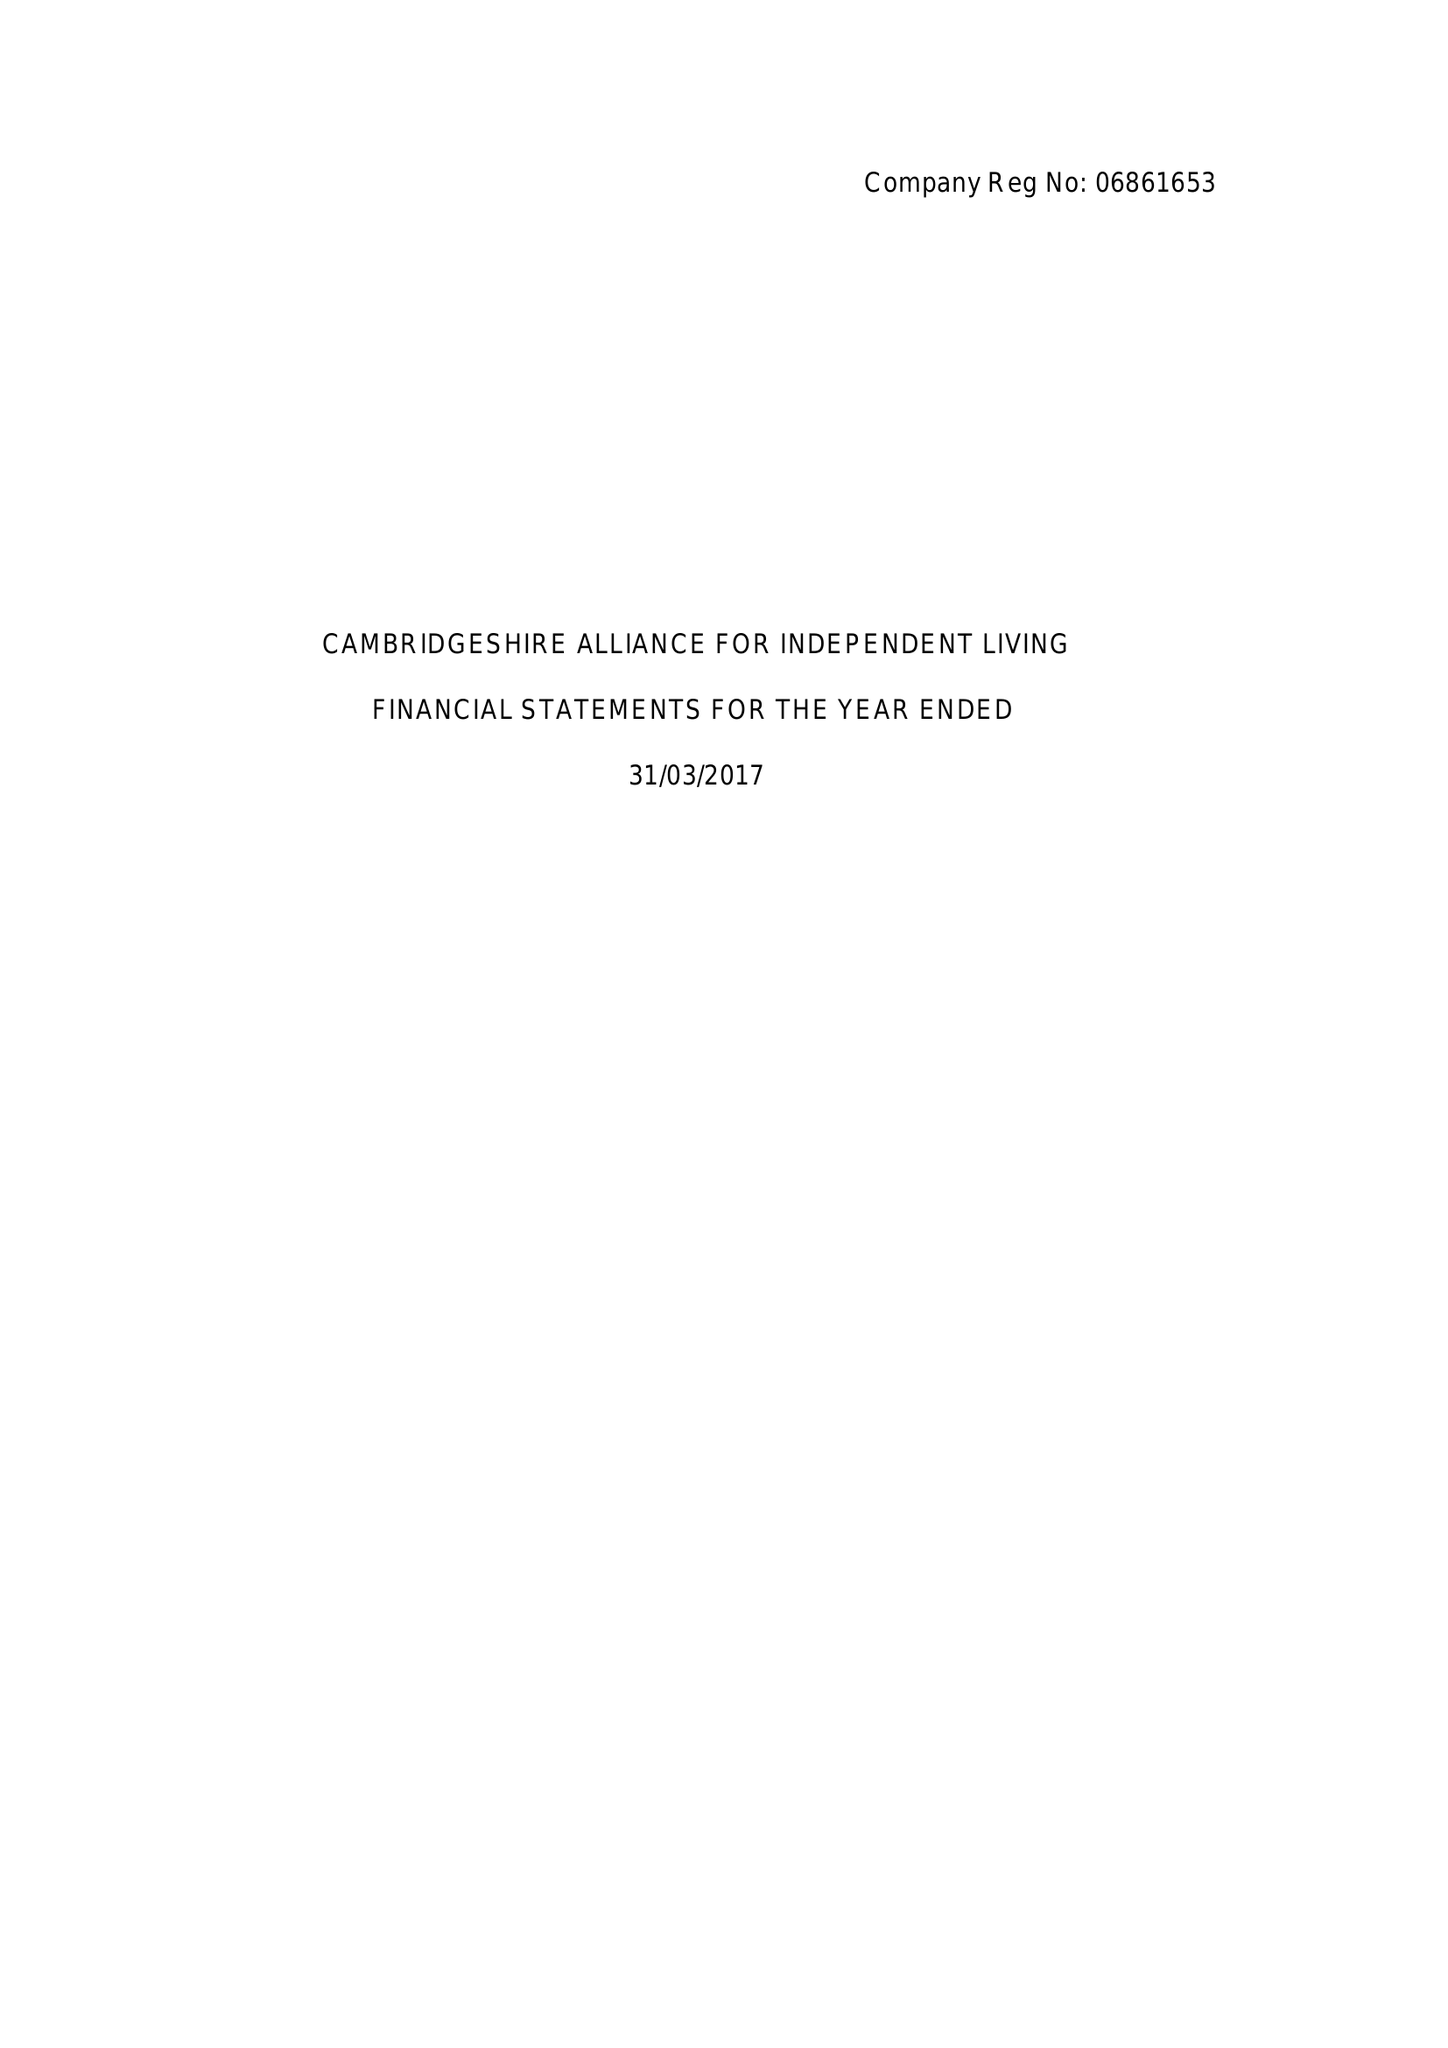What is the value for the spending_annually_in_british_pounds?
Answer the question using a single word or phrase. 114918.00 